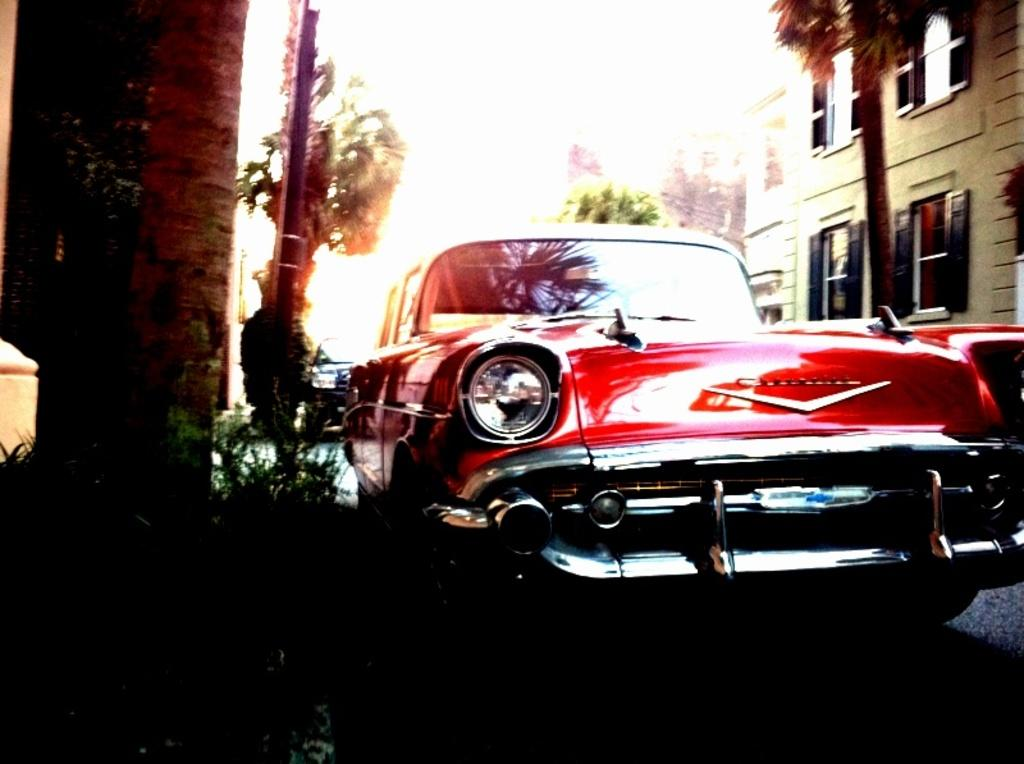What is the main subject in the foreground of the image? There is a car in the foreground of the image. What else can be seen on the road in the foreground? There are vehicles on the road in the foreground. What can be seen in the background of the image? There are buildings, trees, windows, and the sky visible in the background. What type of location is depicted in the image? The image is taken on the road. What type of stick can be seen forming a respectful salute in the image? There is no stick or salute present in the image. 